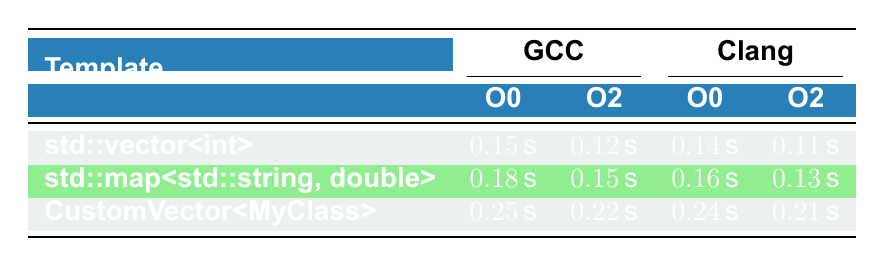What is the compilation time for std::vector<int> using Clang with optimization level O2? The table indicates that for std::vector<int>, the compilation time using Clang at optimization level O2 is 0.11 seconds.
Answer: 0.11 seconds What is the difference in compilation time between std::map<std::string, double> at optimization levels O0 and O2 using GCC? For std::map<std::string, double> with GCC, the compilation times are 0.18 seconds at O0 and 0.15 seconds at O2. The difference is 0.18 - 0.15 = 0.03 seconds.
Answer: 0.03 seconds Is the compilation time for CustomVector<MyClass> higher than that for std::vector<int> using Clang with optimization level O0? The compilation time for CustomVector<MyClass> using Clang at O0 is 0.24 seconds, while std::vector<int> is 0.14 seconds. Since 0.24 is greater than 0.14, the statement is true.
Answer: Yes What are the average compilation times for the templates using GCC at optimization level O2? The compilation times at O2 for GCC are 0.12 for std::vector<int>, 0.15 for std::map<std::string, double>, and 0.22 for CustomVector<MyClass}. The average is calculated as (0.12 + 0.15 + 0.22) / 3 = 0.16 seconds.
Answer: 0.16 seconds Which compiler and optimization level produced the fastest compilation time for std::vector<int>? The fastest compilation time for std::vector<int> is with Clang at O2, which is 0.11 seconds.
Answer: Clang O2 What is the total compilation time for all templates using Clang at optimization level O0? The compilation times for Clang at O0 are 0.14 for std::vector<int>, 0.16 for std::map<std::string, double>, and 0.24 for CustomVector<MyClass}. The total is 0.14 + 0.16 + 0.24 = 0.54 seconds.
Answer: 0.54 seconds Did CustomVector<MyClass> have a shorter compilation time than std::map<std::string, double> when using GCC with optimization level O2? The compilation time for CustomVector<MyClass> at O2 using GCC is 0.22 seconds and for std::map<std::string, double> is 0.15 seconds. Since 0.22 is greater than 0.15, the statement is false.
Answer: No What were the compilation times for std::vector<int> across all compiler settings? The compilation times are 0.15 seconds with GCC O0, 0.12 seconds with GCC O2, 0.14 seconds with Clang O0, and 0.11 seconds with Clang O2.
Answer: 0.15, 0.12, 0.14, 0.11 seconds 